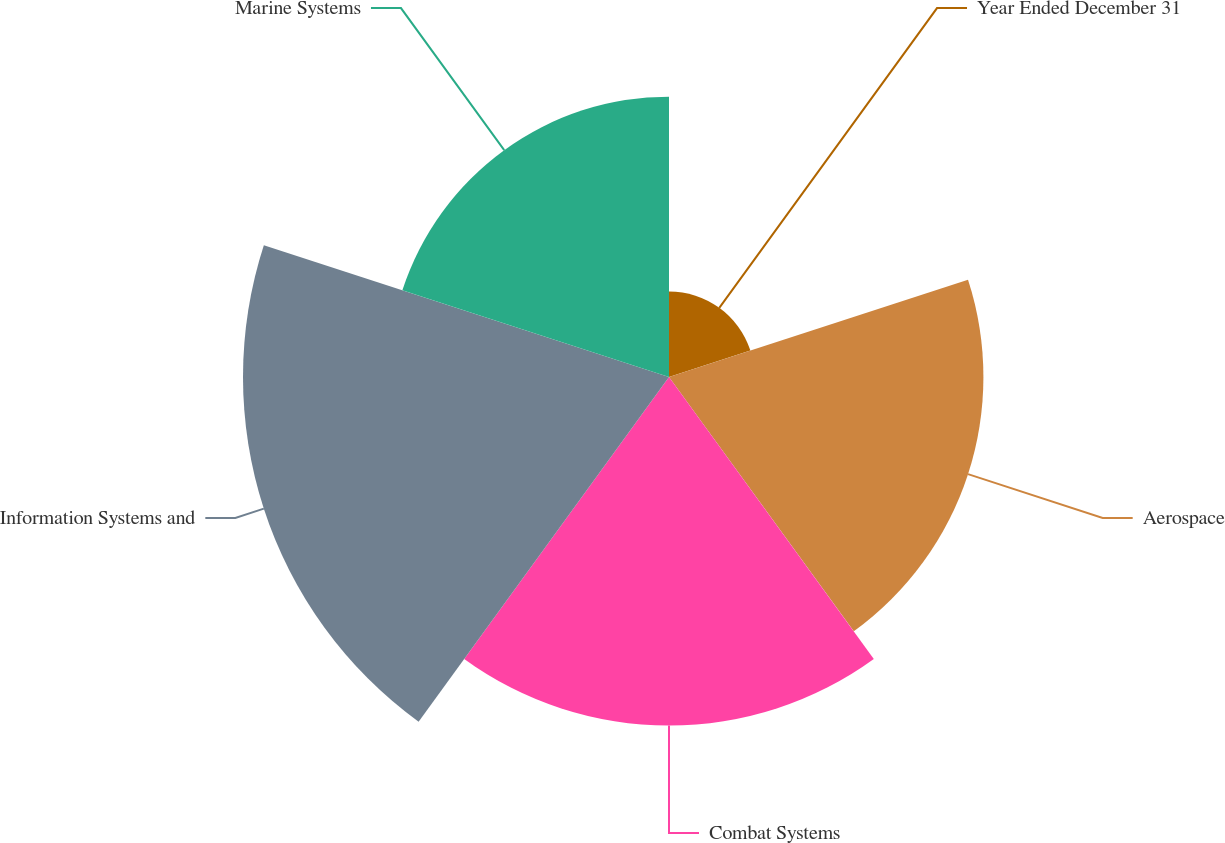Convert chart. <chart><loc_0><loc_0><loc_500><loc_500><pie_chart><fcel>Year Ended December 31<fcel>Aerospace<fcel>Combat Systems<fcel>Information Systems and<fcel>Marine Systems<nl><fcel>5.88%<fcel>21.61%<fcel>23.95%<fcel>29.28%<fcel>19.27%<nl></chart> 